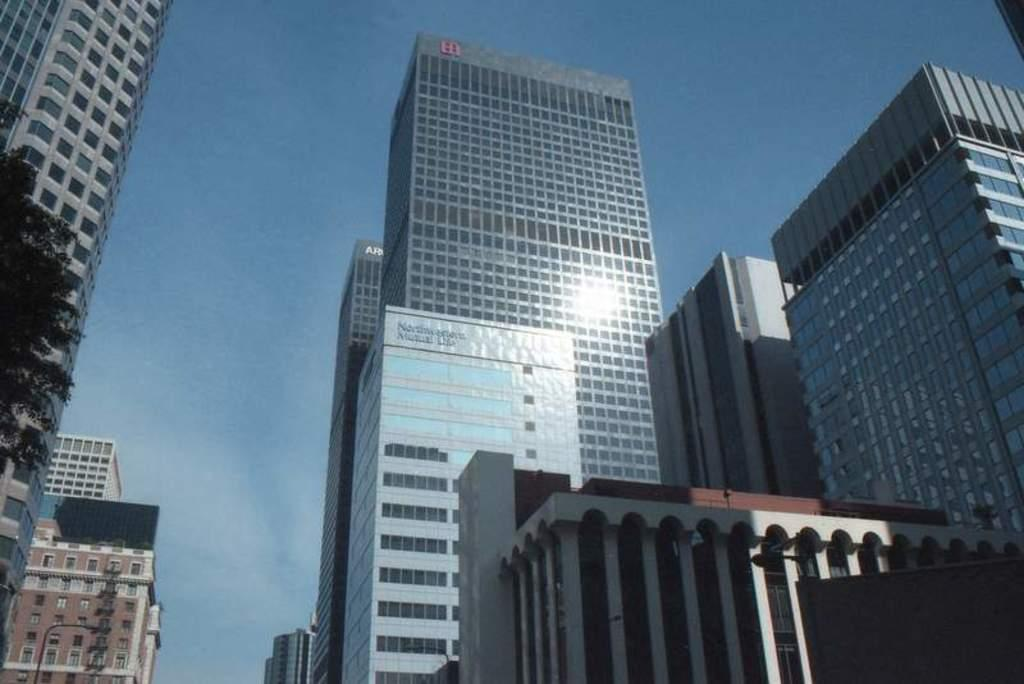What type of structures are visible in the image? There are visible in the image? What type of natural element is present in the image? There is a tree in the image. What are the tall, vertical objects with signs or lights in the image? There are street poles in the image. What is visible in the background of the image? The sky is visible in the image. Can you tell me what date is marked on the calendar in the image? There is no calendar present in the image, so it is not possible to determine the date. 